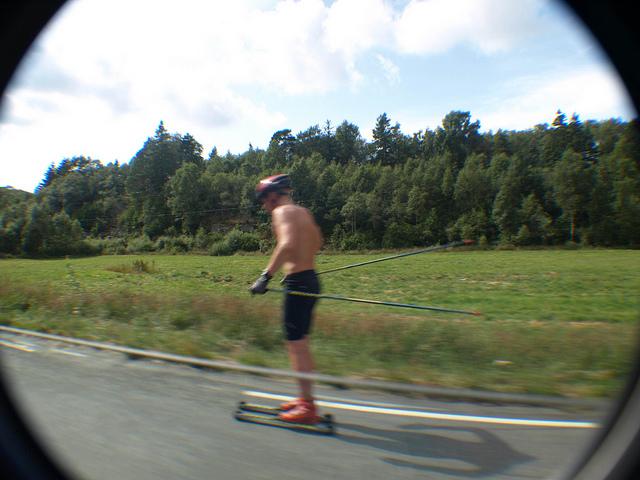What is the man doing?
Be succinct. Skateboarding. Is the man wearing any shoes?
Quick response, please. Yes. What is in the man's hands?
Concise answer only. Poles. 